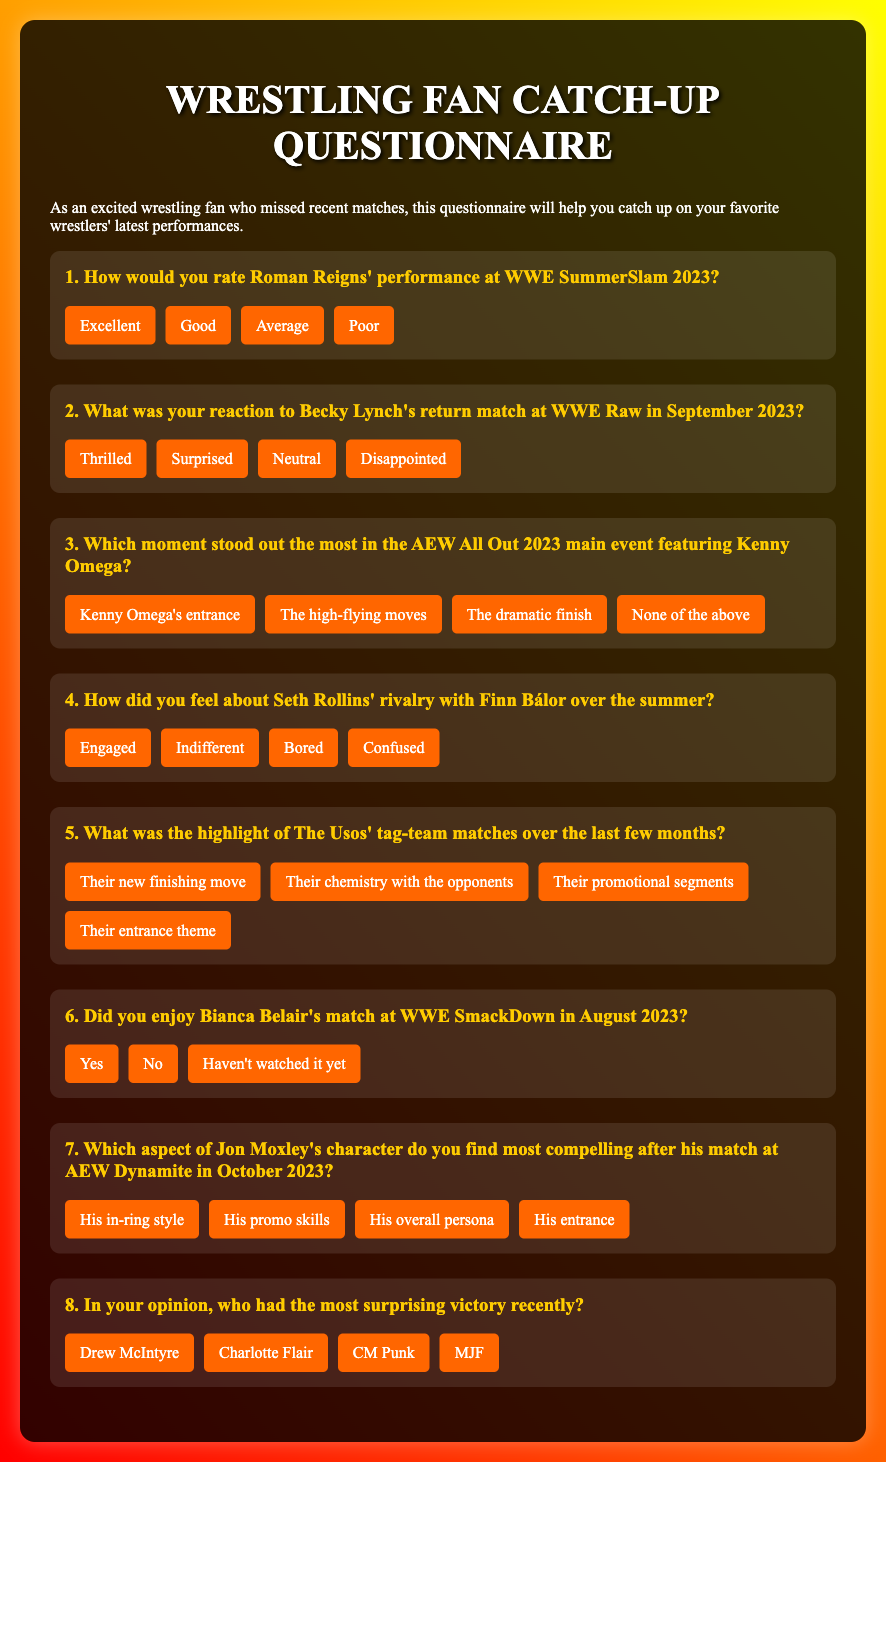What is the title of the document? The title is presented prominently at the top of the document.
Answer: Wrestling Fan Catch-Up Questionnaire How many questions are in the document? The document lists a series of performance-related questions, and there are a total of eight questions.
Answer: 8 What event features Roman Reigns' performance? The document specifies the event at which Roman Reigns performed.
Answer: WWE SummerSlam 2023 Who had a return match at WWE Raw in September 2023? The document mentions a specific wrestler's return match during a particular event.
Answer: Becky Lynch What emotion does the second question ask respondents to express for Becky Lynch's match? The second question focuses on the respondents' reactions to a specific event involving a wrestler.
Answer: Reaction What significant moment does the third question reference in the All Out 2023 main event? The question in the document highlights a notable occurrence during a wrestling event.
Answer: Dramatic finish What does the sixth question ask about Bianca Belair? The sixth question seeks a specific response regarding the enjoyment of a particular match.
Answer: Enjoyment Which wrestler does the eighth question mention as having a recent surprising victory? The eighth question asks about unexpected victories and lists options to choose from, including a specific wrestler.
Answer: CM Punk 